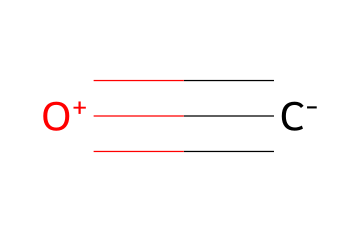What is the molecular formula of this gas? The chemical is represented by the SMILES notation "[C-]#[O+]", indicating one carbon (C) and one oxygen (O) atom. Thus, the molecular formula can be derived as CO.
Answer: CO How many bonds are present in this molecule? The representation shows a triple bond (indicated by "###") between carbon and oxygen. Therefore, there is one triple bond in the structure.
Answer: 1 What type of bond connects the carbon and oxygen atoms? The "#" symbol in the SMILES notation signifies that there is a triple bond between the carbon and the oxygen atoms.
Answer: triple bond What charge does the oxygen atom carry in this gas? The SMILES representation includes "[O+]", indicating that the oxygen atom has a positive charge.
Answer: positive Why is carbon monoxide considered toxic? The molecule's configuration allows it to bind with hemoglobin in the blood more effectively than oxygen, which disrupts oxygen transport and creates toxicity.
Answer: binding with hemoglobin Is carbon monoxide a natural or anthropogenic gas? While carbon monoxide can be produced naturally through processes like wildfires, significant levels are predominantly a result of human activities, such as vehicle emissions and industrial processes.
Answer: anthropogenic 